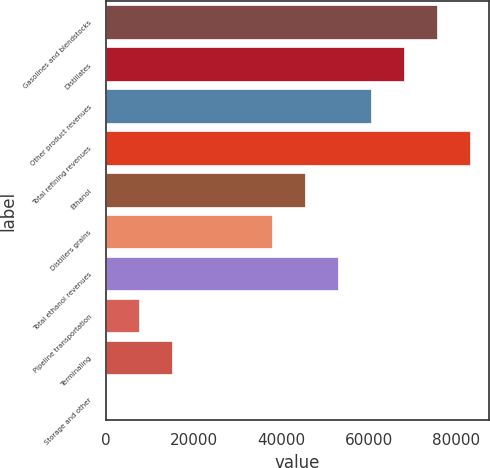Convert chart to OTSL. <chart><loc_0><loc_0><loc_500><loc_500><bar_chart><fcel>Gasolines and blendstocks<fcel>Distillates<fcel>Other product revenues<fcel>Total refining revenues<fcel>Ethanol<fcel>Distillers grains<fcel>Total ethanol revenues<fcel>Pipeline transportation<fcel>Terminaling<fcel>Storage and other<nl><fcel>75659<fcel>68093.2<fcel>60527.4<fcel>83224.8<fcel>45395.8<fcel>37830<fcel>52961.6<fcel>7566.8<fcel>15132.6<fcel>1<nl></chart> 